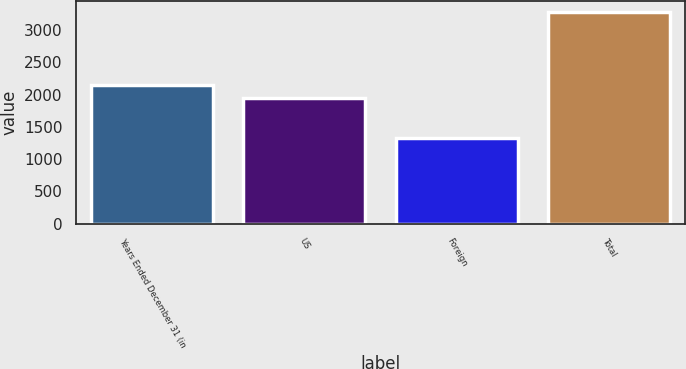Convert chart. <chart><loc_0><loc_0><loc_500><loc_500><bar_chart><fcel>Years Ended December 31 (in<fcel>US<fcel>Foreign<fcel>Total<nl><fcel>2145<fcel>1950<fcel>1331<fcel>3281<nl></chart> 